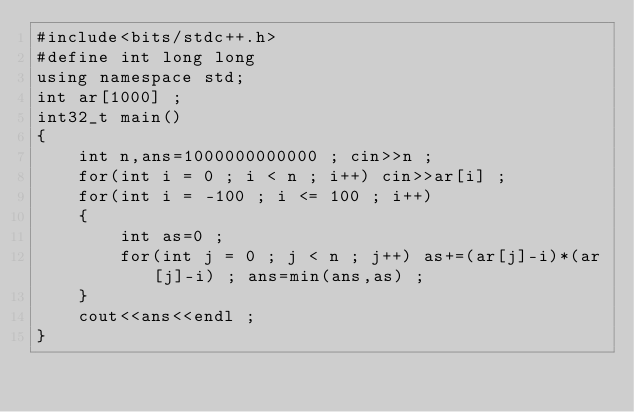<code> <loc_0><loc_0><loc_500><loc_500><_C++_>#include<bits/stdc++.h>
#define int long long
using namespace std;
int ar[1000] ;
int32_t main()
{
    int n,ans=1000000000000 ; cin>>n ;
    for(int i = 0 ; i < n ; i++) cin>>ar[i] ;
    for(int i = -100 ; i <= 100 ; i++)
    {
        int as=0 ;
        for(int j = 0 ; j < n ; j++) as+=(ar[j]-i)*(ar[j]-i) ; ans=min(ans,as) ;
    }
    cout<<ans<<endl ;
}
</code> 